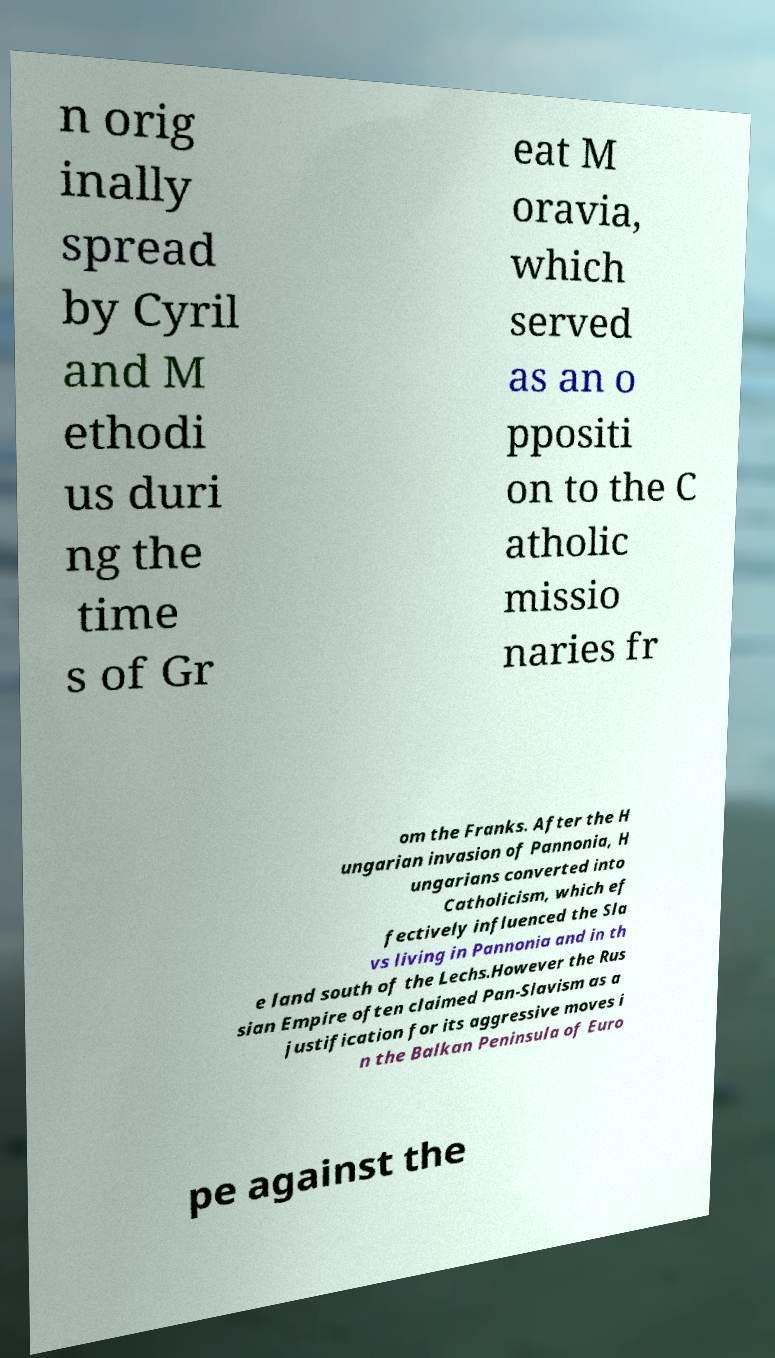Could you extract and type out the text from this image? n orig inally spread by Cyril and M ethodi us duri ng the time s of Gr eat M oravia, which served as an o ppositi on to the C atholic missio naries fr om the Franks. After the H ungarian invasion of Pannonia, H ungarians converted into Catholicism, which ef fectively influenced the Sla vs living in Pannonia and in th e land south of the Lechs.However the Rus sian Empire often claimed Pan-Slavism as a justification for its aggressive moves i n the Balkan Peninsula of Euro pe against the 